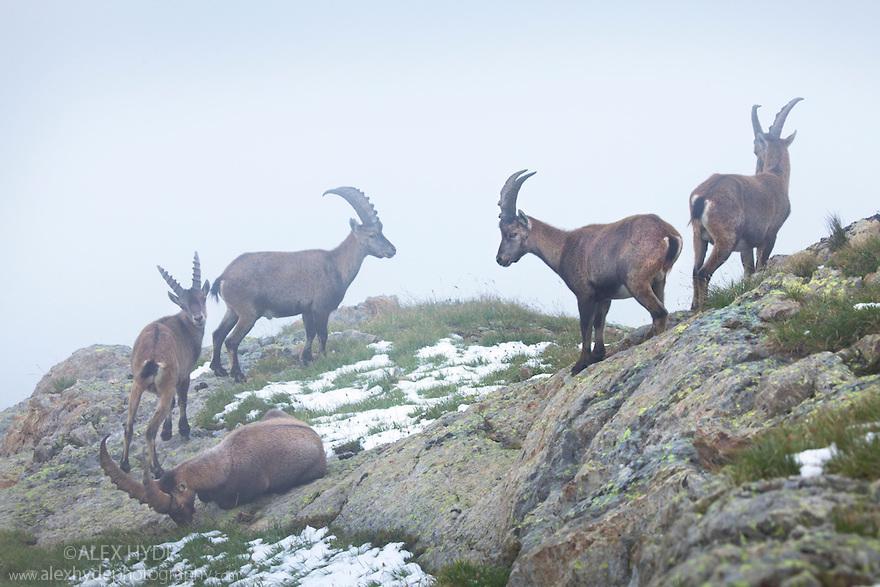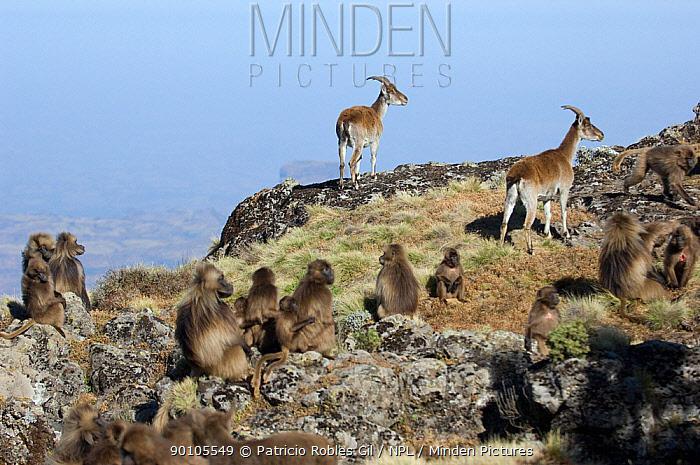The first image is the image on the left, the second image is the image on the right. Given the left and right images, does the statement "There's no more than one mountain goat in the right image." hold true? Answer yes or no. No. The first image is the image on the left, the second image is the image on the right. Examine the images to the left and right. Is the description "One animal is standing on two feet in the image on the left." accurate? Answer yes or no. No. 